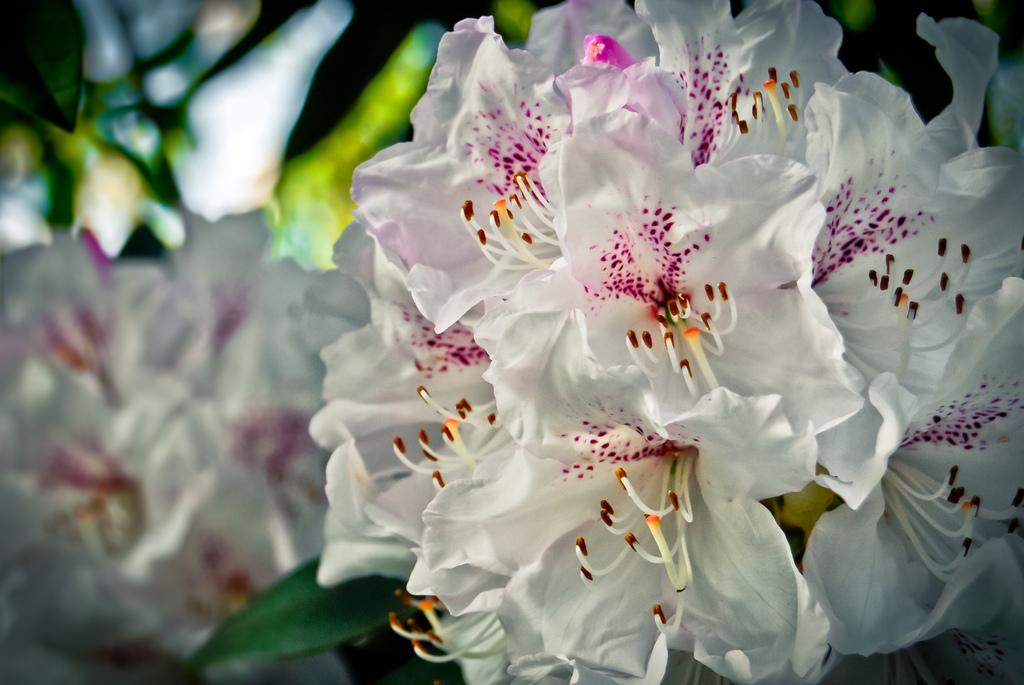What type of flora is present in the image? There are flowers in the image. What color are the flowers? The flowers are white in color. What can be seen in the background of the image? The background of the image is green. How is the background of the image depicted? The background is blurred. Can you tell me how many combs are used to style the flowers in the image? There are no combs present in the image, as it features flowers and a green background. 